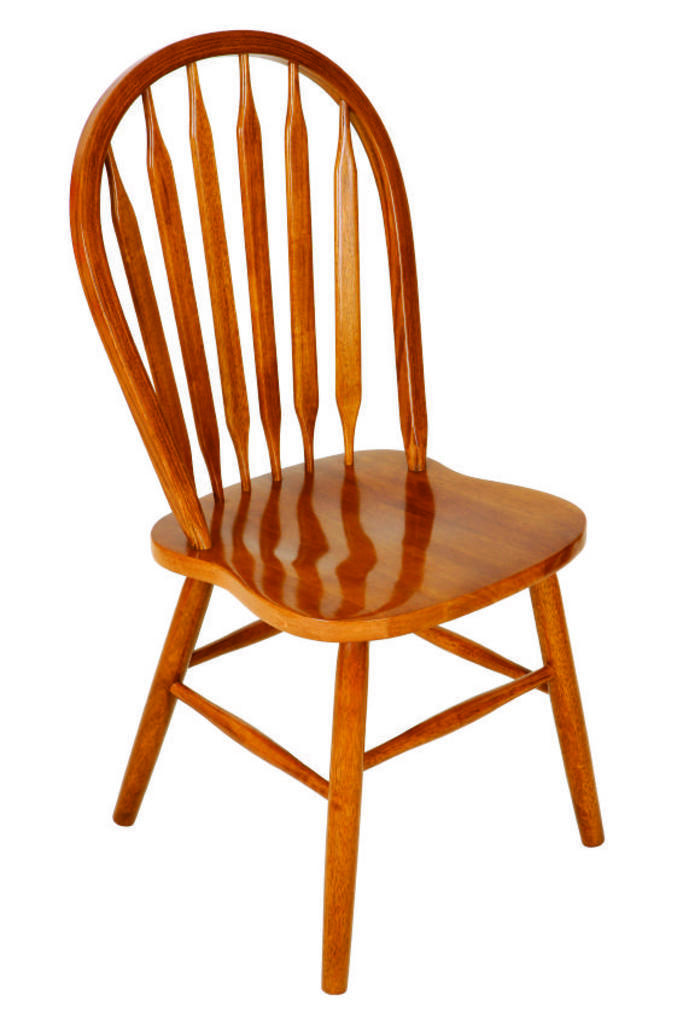What type of chair is in the image? There is a wooden chair in the image. What color is the background of the image? The background of the image is white. How many rings are on the wooden chair in the image? There are no rings present on the wooden chair in the image. 